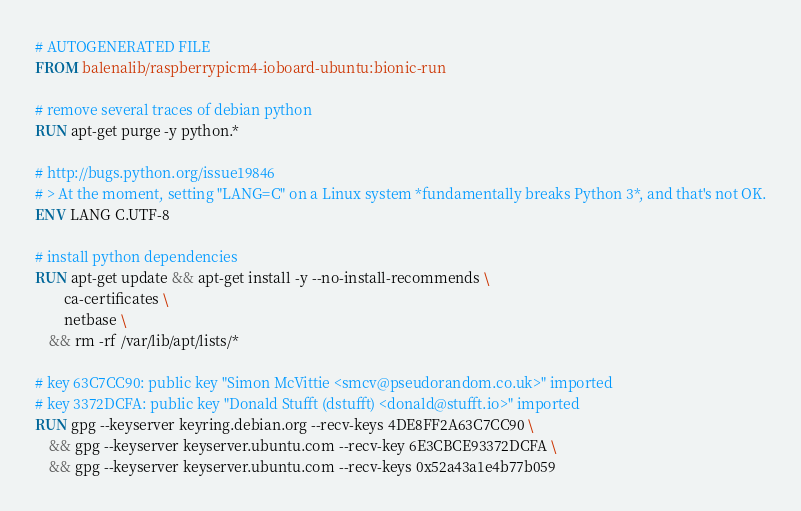Convert code to text. <code><loc_0><loc_0><loc_500><loc_500><_Dockerfile_># AUTOGENERATED FILE
FROM balenalib/raspberrypicm4-ioboard-ubuntu:bionic-run

# remove several traces of debian python
RUN apt-get purge -y python.*

# http://bugs.python.org/issue19846
# > At the moment, setting "LANG=C" on a Linux system *fundamentally breaks Python 3*, and that's not OK.
ENV LANG C.UTF-8

# install python dependencies
RUN apt-get update && apt-get install -y --no-install-recommends \
		ca-certificates \
		netbase \
	&& rm -rf /var/lib/apt/lists/*

# key 63C7CC90: public key "Simon McVittie <smcv@pseudorandom.co.uk>" imported
# key 3372DCFA: public key "Donald Stufft (dstufft) <donald@stufft.io>" imported
RUN gpg --keyserver keyring.debian.org --recv-keys 4DE8FF2A63C7CC90 \
	&& gpg --keyserver keyserver.ubuntu.com --recv-key 6E3CBCE93372DCFA \
	&& gpg --keyserver keyserver.ubuntu.com --recv-keys 0x52a43a1e4b77b059
</code> 